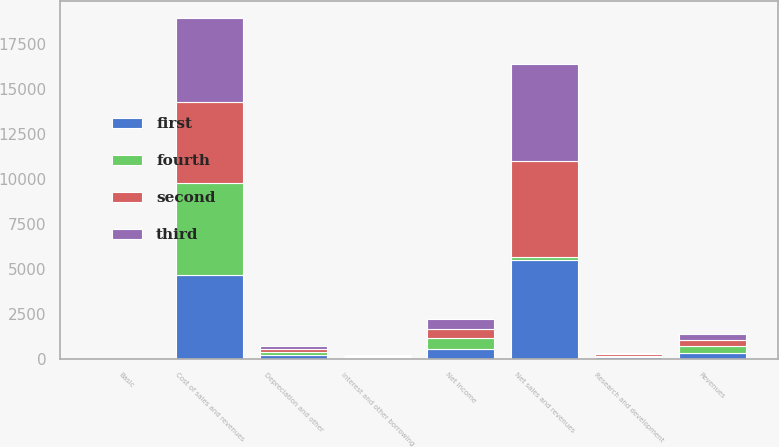<chart> <loc_0><loc_0><loc_500><loc_500><stacked_bar_chart><ecel><fcel>Net sales and revenues<fcel>Cost of sales and revenues<fcel>Research and development<fcel>Revenues<fcel>Interest and other borrowing<fcel>Depreciation and other<fcel>Net Income<fcel>Basic<nl><fcel>second<fcel>5321.8<fcel>4535.5<fcel>76<fcel>332.2<fcel>41.3<fcel>186.4<fcel>512.1<fcel>1.45<nl><fcel>first<fcel>5467.2<fcel>4647.3<fcel>76.7<fcel>338<fcel>45.7<fcel>185.5<fcel>559.6<fcel>1.59<nl><fcel>third<fcel>5416.9<fcel>4653.6<fcel>72.9<fcel>339.9<fcel>49<fcel>178.5<fcel>545.3<fcel>1.55<nl><fcel>fourth<fcel>186.4<fcel>5088.6<fcel>80.5<fcel>347<fcel>50.9<fcel>177.6<fcel>578.1<fcel>1.66<nl></chart> 